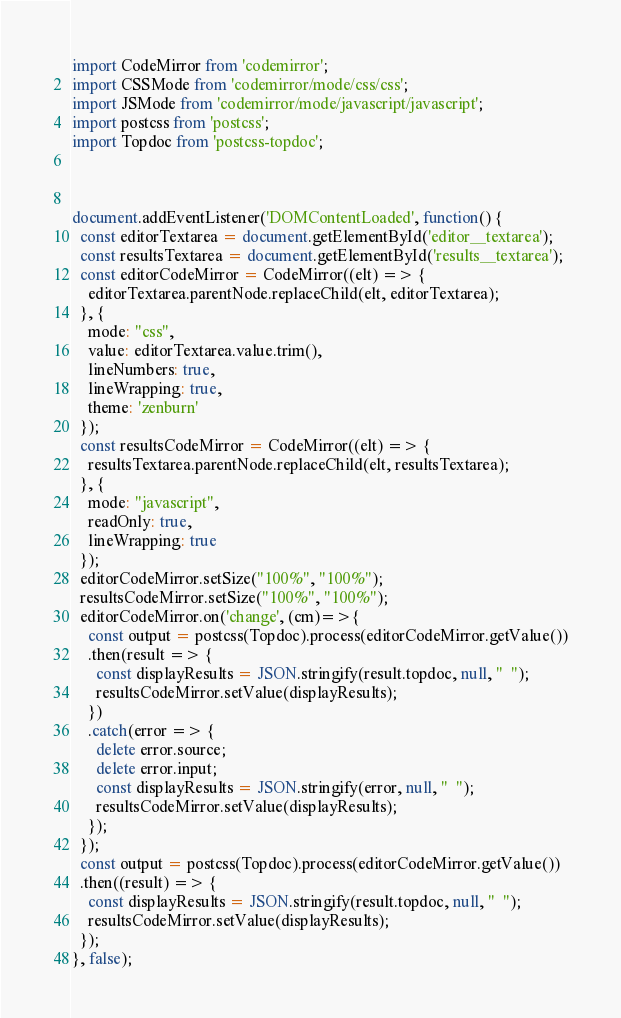Convert code to text. <code><loc_0><loc_0><loc_500><loc_500><_JavaScript_>import CodeMirror from 'codemirror';
import CSSMode from 'codemirror/mode/css/css';
import JSMode from 'codemirror/mode/javascript/javascript';
import postcss from 'postcss';
import Topdoc from 'postcss-topdoc';



document.addEventListener('DOMContentLoaded', function() {
  const editorTextarea = document.getElementById('editor__textarea');
  const resultsTextarea = document.getElementById('results__textarea');
  const editorCodeMirror = CodeMirror((elt) => {
    editorTextarea.parentNode.replaceChild(elt, editorTextarea);
  }, {
    mode: "css",
    value: editorTextarea.value.trim(),
    lineNumbers: true,
    lineWrapping: true,
    theme: 'zenburn'
  });
  const resultsCodeMirror = CodeMirror((elt) => {
    resultsTextarea.parentNode.replaceChild(elt, resultsTextarea);
  }, {
    mode: "javascript",
    readOnly: true,
    lineWrapping: true
  });
  editorCodeMirror.setSize("100%", "100%");
  resultsCodeMirror.setSize("100%", "100%");
  editorCodeMirror.on('change', (cm)=>{
    const output = postcss(Topdoc).process(editorCodeMirror.getValue())
    .then(result => {
      const displayResults = JSON.stringify(result.topdoc, null, "  ");
      resultsCodeMirror.setValue(displayResults);
    })
    .catch(error => {
      delete error.source;
      delete error.input;
      const displayResults = JSON.stringify(error, null, "  ");
      resultsCodeMirror.setValue(displayResults);
    });
  });
  const output = postcss(Topdoc).process(editorCodeMirror.getValue())
  .then((result) => {
    const displayResults = JSON.stringify(result.topdoc, null, "  ");
    resultsCodeMirror.setValue(displayResults);
  });
}, false);
</code> 